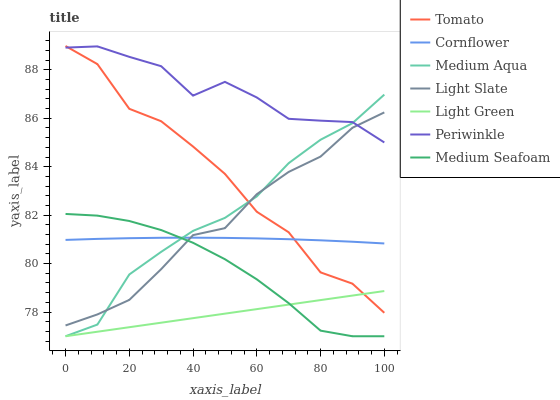Does Light Green have the minimum area under the curve?
Answer yes or no. Yes. Does Periwinkle have the maximum area under the curve?
Answer yes or no. Yes. Does Cornflower have the minimum area under the curve?
Answer yes or no. No. Does Cornflower have the maximum area under the curve?
Answer yes or no. No. Is Light Green the smoothest?
Answer yes or no. Yes. Is Tomato the roughest?
Answer yes or no. Yes. Is Cornflower the smoothest?
Answer yes or no. No. Is Cornflower the roughest?
Answer yes or no. No. Does Light Green have the lowest value?
Answer yes or no. Yes. Does Cornflower have the lowest value?
Answer yes or no. No. Does Tomato have the highest value?
Answer yes or no. Yes. Does Cornflower have the highest value?
Answer yes or no. No. Is Medium Seafoam less than Tomato?
Answer yes or no. Yes. Is Light Slate greater than Light Green?
Answer yes or no. Yes. Does Medium Aqua intersect Cornflower?
Answer yes or no. Yes. Is Medium Aqua less than Cornflower?
Answer yes or no. No. Is Medium Aqua greater than Cornflower?
Answer yes or no. No. Does Medium Seafoam intersect Tomato?
Answer yes or no. No. 